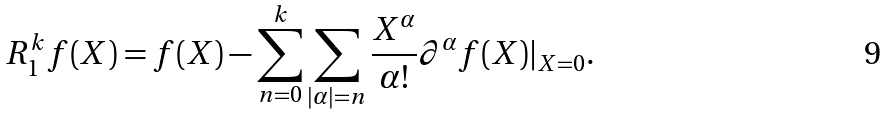<formula> <loc_0><loc_0><loc_500><loc_500>R ^ { k } _ { 1 } f ( X ) = f ( X ) - \sum _ { n = 0 } ^ { k } \sum _ { | \alpha | = n } \frac { X ^ { \alpha } } { \alpha ! } \partial ^ { \alpha } f ( X ) | _ { X = 0 } .</formula> 